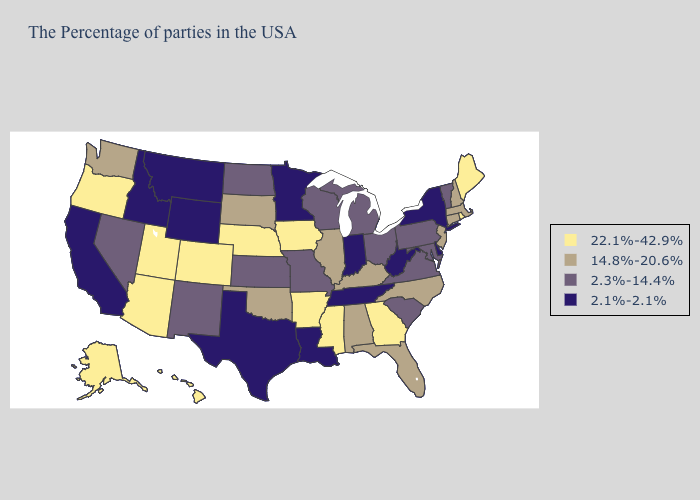Name the states that have a value in the range 2.3%-14.4%?
Write a very short answer. Vermont, Maryland, Pennsylvania, Virginia, South Carolina, Ohio, Michigan, Wisconsin, Missouri, Kansas, North Dakota, New Mexico, Nevada. What is the highest value in states that border Delaware?
Keep it brief. 14.8%-20.6%. Among the states that border New Hampshire , which have the lowest value?
Be succinct. Vermont. Does Missouri have a higher value than New Mexico?
Give a very brief answer. No. Name the states that have a value in the range 22.1%-42.9%?
Keep it brief. Maine, Rhode Island, Georgia, Mississippi, Arkansas, Iowa, Nebraska, Colorado, Utah, Arizona, Oregon, Alaska, Hawaii. Name the states that have a value in the range 22.1%-42.9%?
Short answer required. Maine, Rhode Island, Georgia, Mississippi, Arkansas, Iowa, Nebraska, Colorado, Utah, Arizona, Oregon, Alaska, Hawaii. What is the value of Oregon?
Give a very brief answer. 22.1%-42.9%. What is the value of Maine?
Be succinct. 22.1%-42.9%. Does Oklahoma have a higher value than Alaska?
Be succinct. No. Does Kentucky have the lowest value in the USA?
Quick response, please. No. Does Maine have the lowest value in the Northeast?
Quick response, please. No. What is the lowest value in states that border Washington?
Keep it brief. 2.1%-2.1%. What is the value of Hawaii?
Be succinct. 22.1%-42.9%. Among the states that border Indiana , does Kentucky have the lowest value?
Give a very brief answer. No. What is the value of Kentucky?
Give a very brief answer. 14.8%-20.6%. 